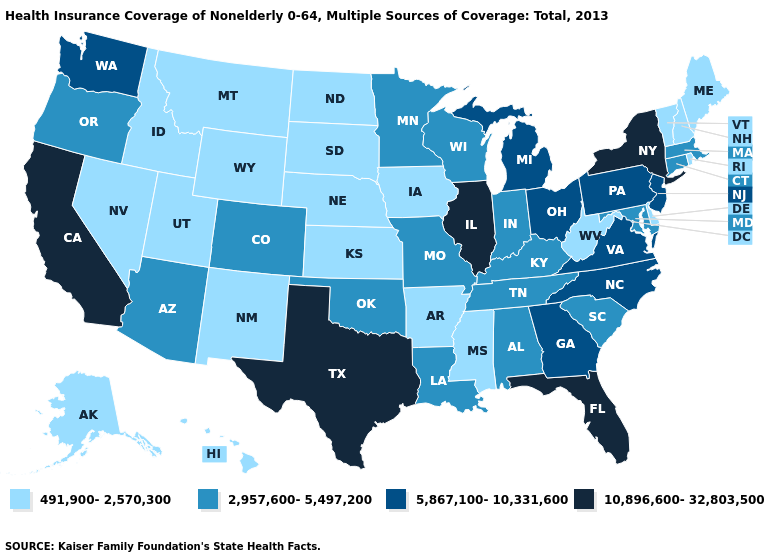Name the states that have a value in the range 10,896,600-32,803,500?
Answer briefly. California, Florida, Illinois, New York, Texas. What is the highest value in states that border North Carolina?
Quick response, please. 5,867,100-10,331,600. Does Louisiana have the same value as Maine?
Short answer required. No. Is the legend a continuous bar?
Quick response, please. No. Does Delaware have the lowest value in the South?
Concise answer only. Yes. Does Iowa have the lowest value in the MidWest?
Keep it brief. Yes. What is the lowest value in the USA?
Short answer required. 491,900-2,570,300. What is the value of Illinois?
Quick response, please. 10,896,600-32,803,500. What is the value of Illinois?
Give a very brief answer. 10,896,600-32,803,500. Name the states that have a value in the range 5,867,100-10,331,600?
Short answer required. Georgia, Michigan, New Jersey, North Carolina, Ohio, Pennsylvania, Virginia, Washington. What is the lowest value in states that border Florida?
Be succinct. 2,957,600-5,497,200. Name the states that have a value in the range 491,900-2,570,300?
Keep it brief. Alaska, Arkansas, Delaware, Hawaii, Idaho, Iowa, Kansas, Maine, Mississippi, Montana, Nebraska, Nevada, New Hampshire, New Mexico, North Dakota, Rhode Island, South Dakota, Utah, Vermont, West Virginia, Wyoming. What is the value of Nevada?
Quick response, please. 491,900-2,570,300. Does the map have missing data?
Concise answer only. No. What is the value of Delaware?
Concise answer only. 491,900-2,570,300. 